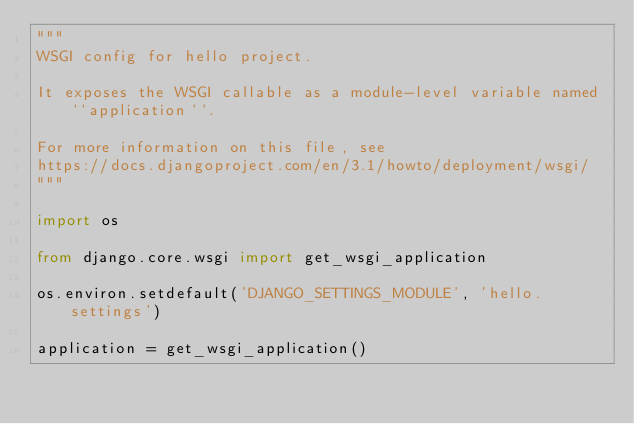<code> <loc_0><loc_0><loc_500><loc_500><_Python_>"""
WSGI config for hello project.

It exposes the WSGI callable as a module-level variable named ``application``.

For more information on this file, see
https://docs.djangoproject.com/en/3.1/howto/deployment/wsgi/
"""

import os

from django.core.wsgi import get_wsgi_application

os.environ.setdefault('DJANGO_SETTINGS_MODULE', 'hello.settings')

application = get_wsgi_application()
</code> 